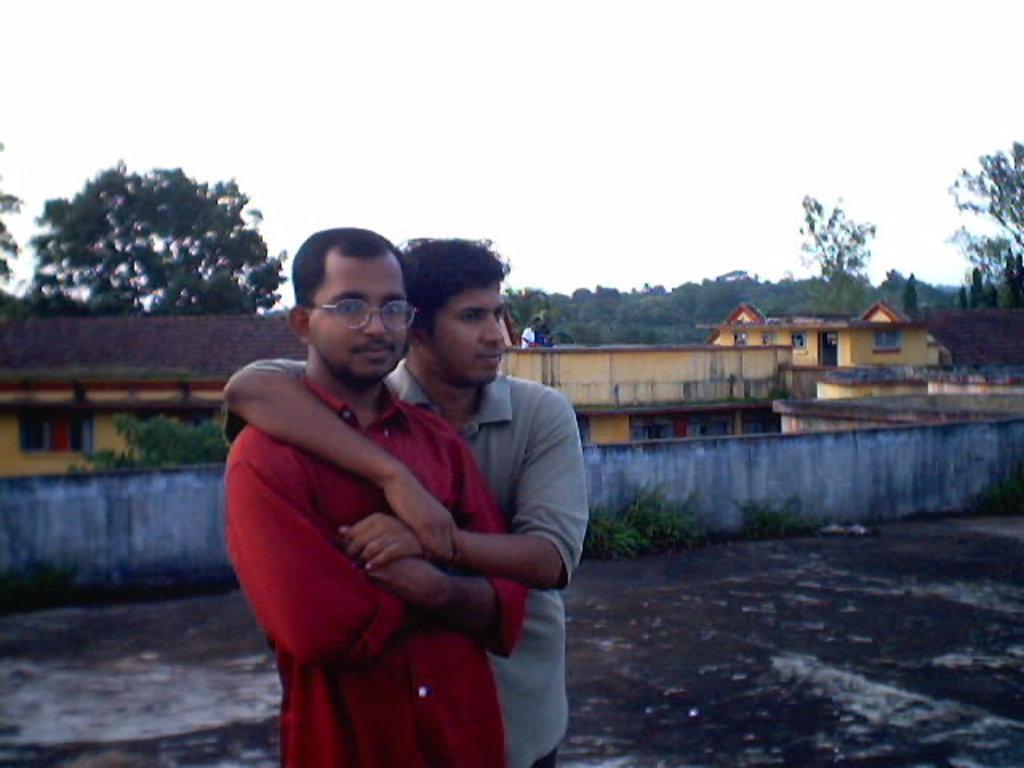Can you describe this image briefly? In this image we can see two men standing. On the backside we can see a wall, a person standing, some buildings, plants, a group of trees and the sky which looks cloudy. 